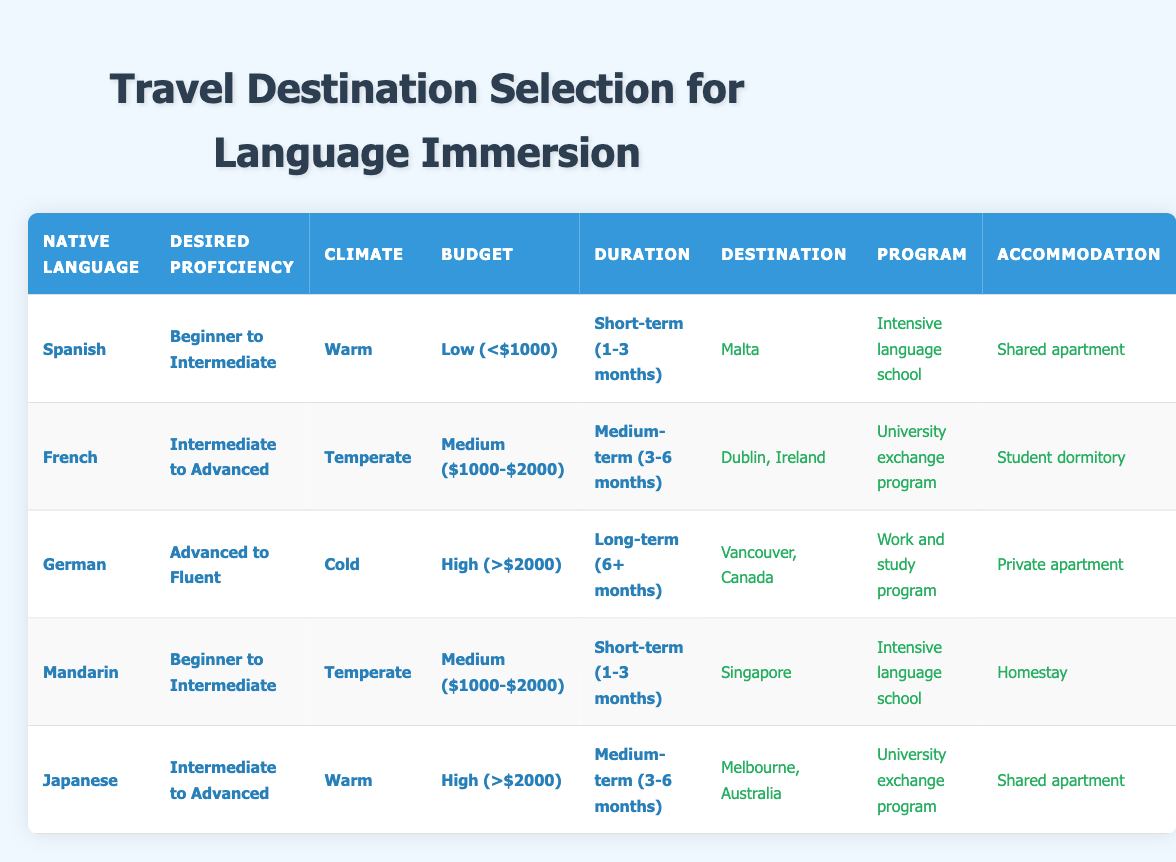What is the recommended destination for someone whose native language is Spanish and wants to improve from beginner to intermediate? Looking at the table, under the row where the native language is Spanish and the desired proficiency improvement is beginner to intermediate, the recommended destination is Malta.
Answer: Malta Which program is suggested for those who want to improve their English from Intermediate to Advanced while living in Dublin, Ireland? In the table, for the row where the recommended destination is Dublin, Ireland, and the desired proficiency level is Intermediate to Advanced, the suggested program is a university exchange program.
Answer: University exchange program Is there a recommended destination for speakers of Mandarin looking for warm climates? In the table, there is no row that lists Mandarin speakers seeking a warm climate. Therefore, the answer is no.
Answer: No What accommodation type is recommended for a German native speaker staying in Vancouver for the long term? Referring to the row where the native language is German, the budget is high, and the preferred duration is long-term, the accommodation type recommended is a private apartment.
Answer: Private apartment How many options are there for the preferred climate listed in the table? The table lists three climate options: warm, temperate, and cold. Therefore, the total number of options is 3.
Answer: 3 If a Japanese speaker wants to stay for a short-term duration, which destination offers that option? Looking through the table, there are no entries for Japanese speakers desiring a short-term stay. The answer is negative for that question.
Answer: No What is the suggested budget per month for someone who wants to improve their English from beginner to intermediate while studying in Singapore? In the row corresponding to Mandarin native speakers wanting to improve from beginner to intermediate in Singapore, the suggested budget per month is medium, which ranges from $1000 to $2000.
Answer: Medium ($1000-$2000) Can a person who is looking for a warm climate and a low budget find a suitable program in the table? By reviewing the conditions, a low budget and warm climate are matched with Malta, which suggests an intensive language school program for Spanish speakers. Thus, there is a suitable program.
Answer: Yes What is the average duration preferred in the table for those aiming for advanced to fluent proficiency? The only row for advanced to fluent proficiency corresponds to the German native speaker, who prefers a long-term duration of 6 months or more. Therefore, the average duration is also long-term (6+ months) based on a single entry.
Answer: Long-term (6+ months) 